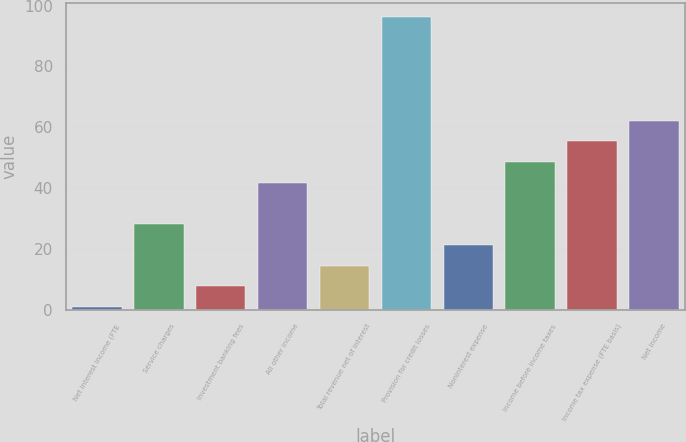<chart> <loc_0><loc_0><loc_500><loc_500><bar_chart><fcel>Net interest income (FTE<fcel>Service charges<fcel>Investment banking fees<fcel>All other income<fcel>Total revenue net of interest<fcel>Provision for credit losses<fcel>Noninterest expense<fcel>Income before income taxes<fcel>Income tax expense (FTE basis)<fcel>Net income<nl><fcel>1<fcel>28.2<fcel>7.8<fcel>41.8<fcel>14.6<fcel>96.2<fcel>21.4<fcel>48.6<fcel>55.4<fcel>62.2<nl></chart> 